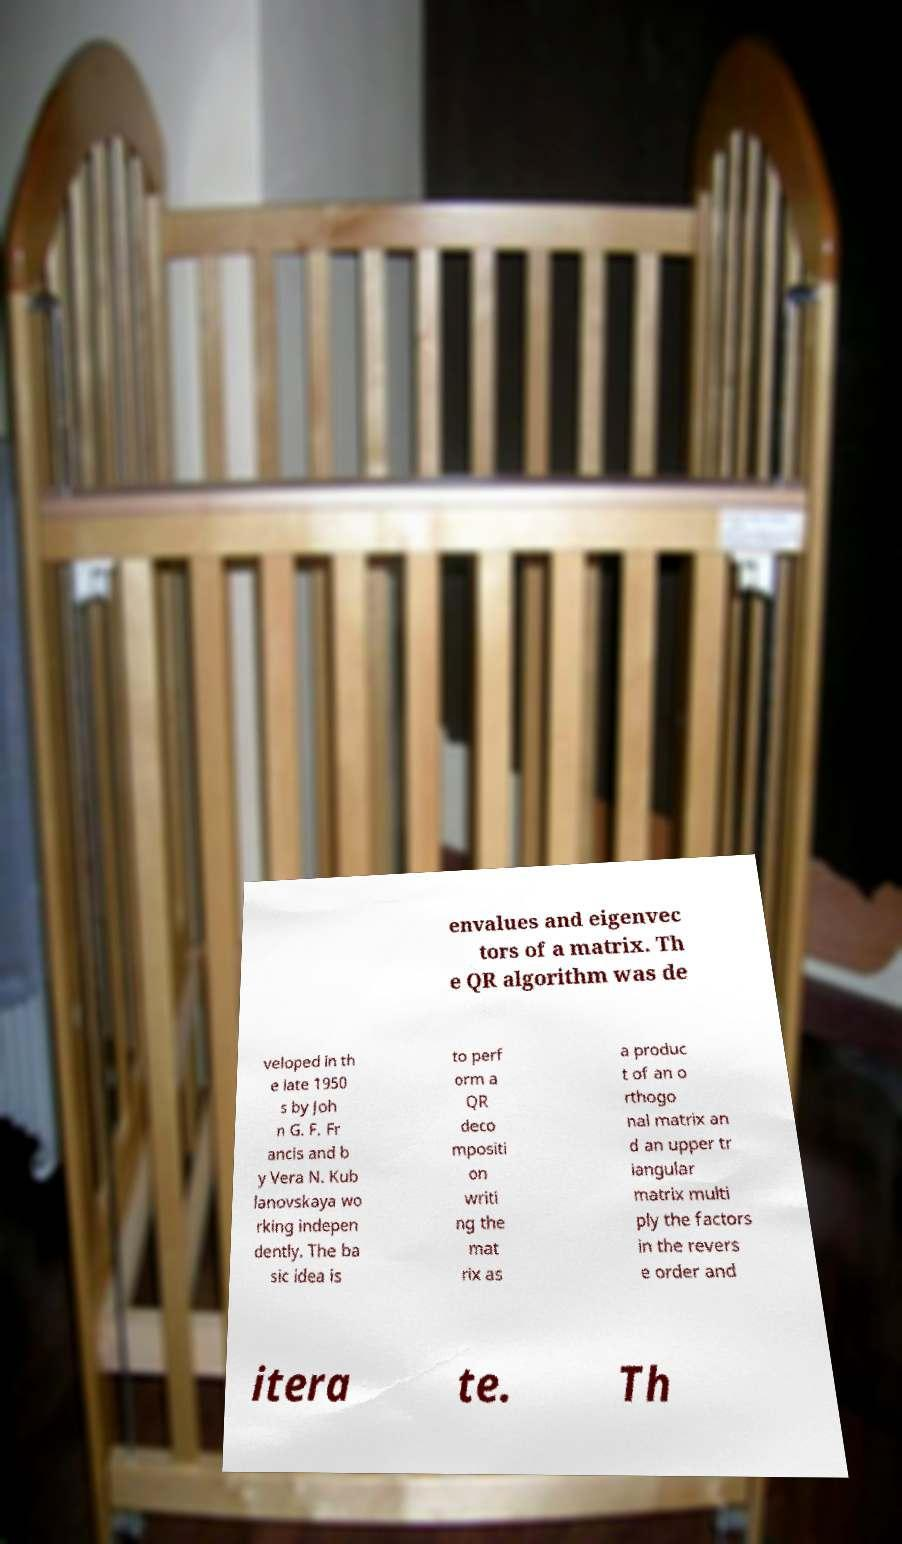For documentation purposes, I need the text within this image transcribed. Could you provide that? envalues and eigenvec tors of a matrix. Th e QR algorithm was de veloped in th e late 1950 s by Joh n G. F. Fr ancis and b y Vera N. Kub lanovskaya wo rking indepen dently. The ba sic idea is to perf orm a QR deco mpositi on writi ng the mat rix as a produc t of an o rthogo nal matrix an d an upper tr iangular matrix multi ply the factors in the revers e order and itera te. Th 